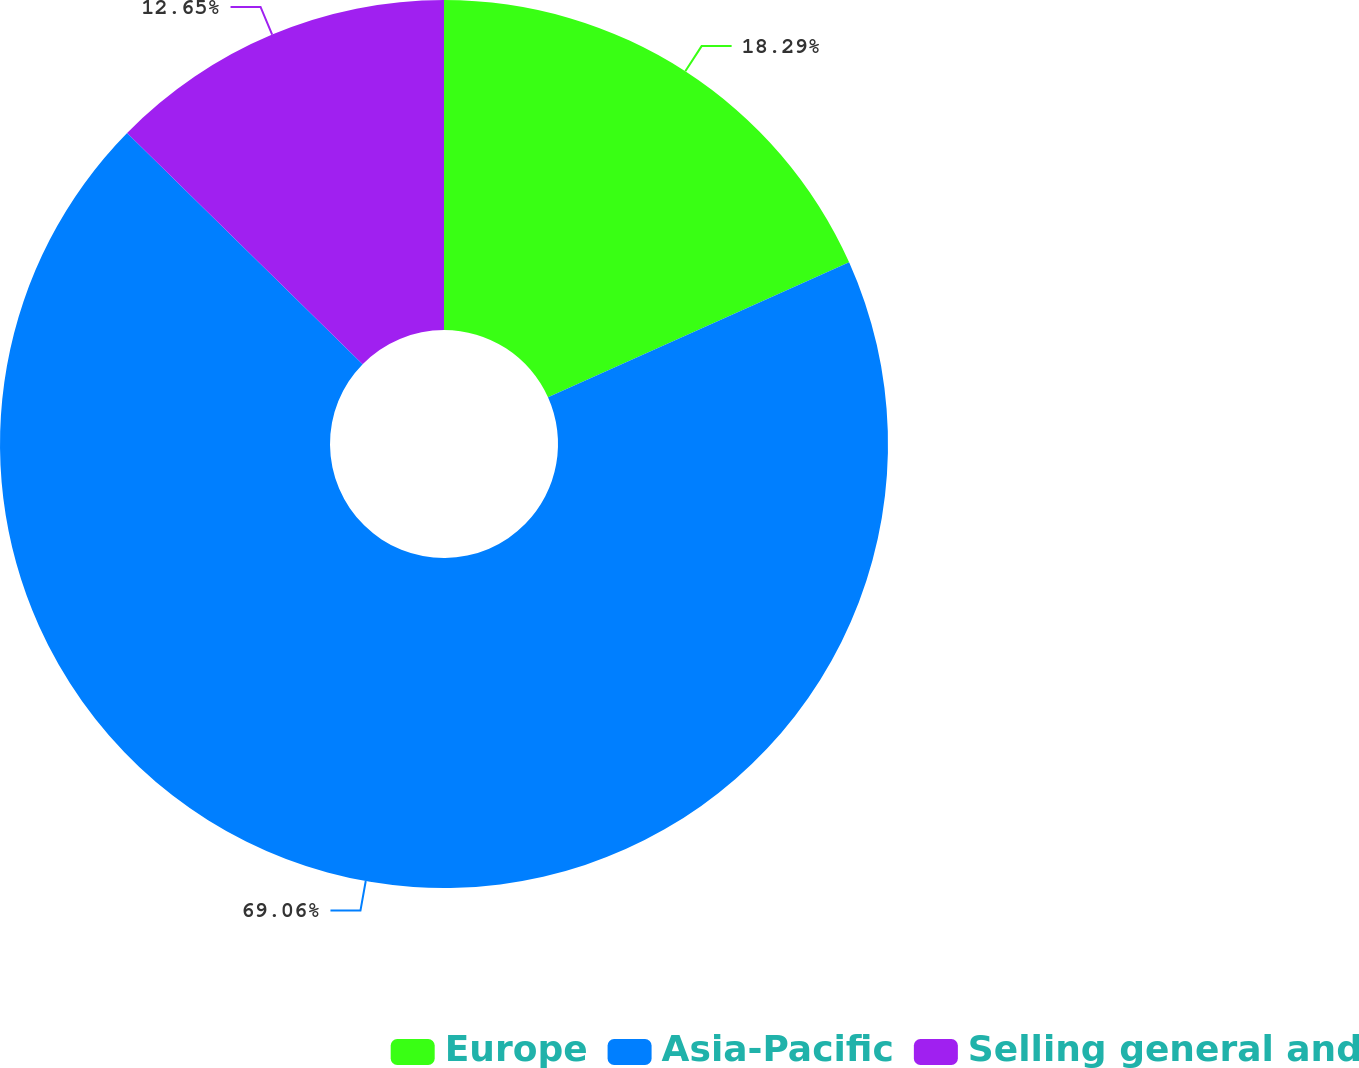Convert chart to OTSL. <chart><loc_0><loc_0><loc_500><loc_500><pie_chart><fcel>Europe<fcel>Asia-Pacific<fcel>Selling general and<nl><fcel>18.29%<fcel>69.06%<fcel>12.65%<nl></chart> 